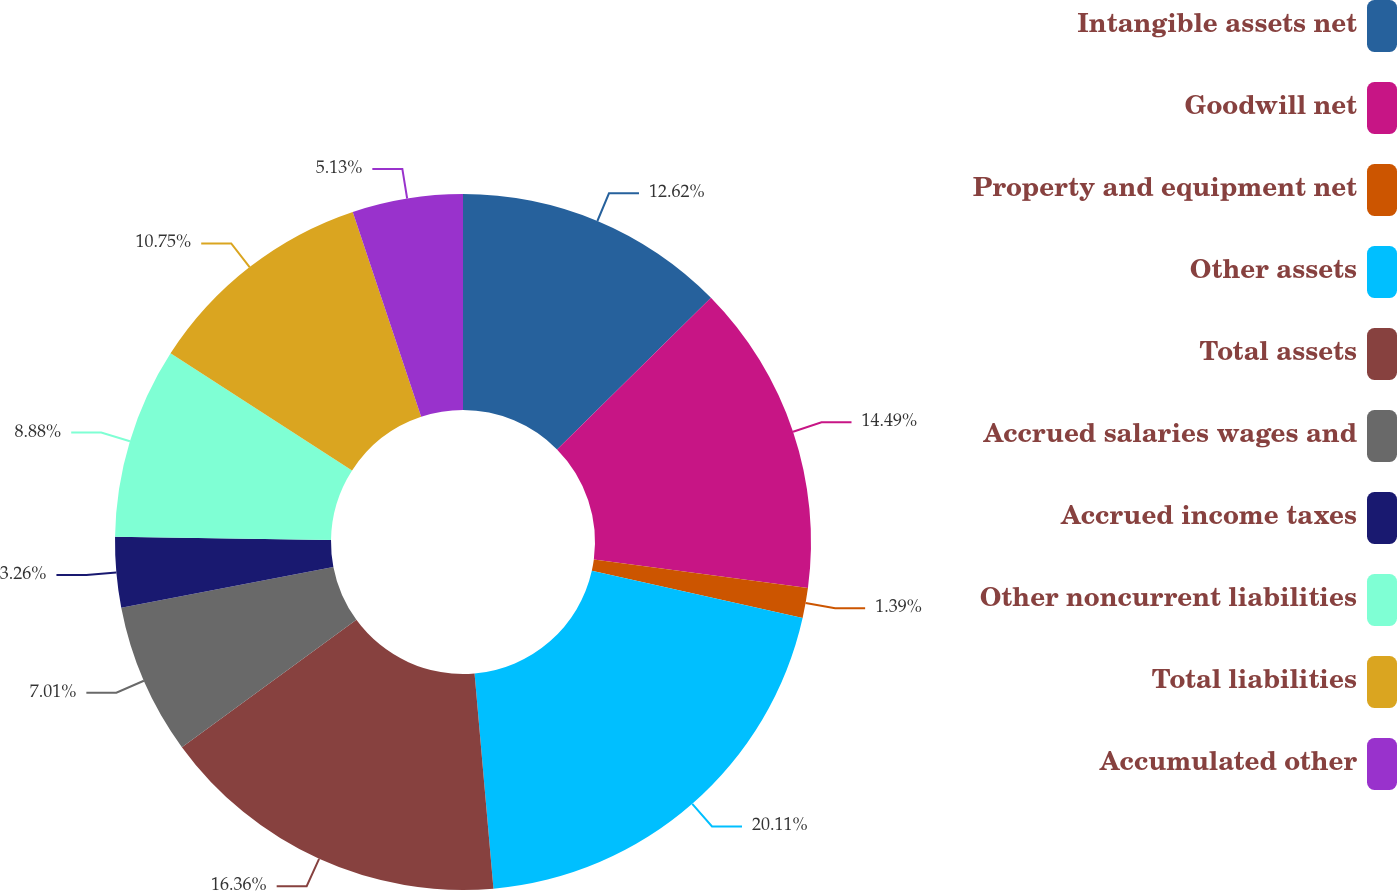<chart> <loc_0><loc_0><loc_500><loc_500><pie_chart><fcel>Intangible assets net<fcel>Goodwill net<fcel>Property and equipment net<fcel>Other assets<fcel>Total assets<fcel>Accrued salaries wages and<fcel>Accrued income taxes<fcel>Other noncurrent liabilities<fcel>Total liabilities<fcel>Accumulated other<nl><fcel>12.62%<fcel>14.49%<fcel>1.39%<fcel>20.1%<fcel>16.36%<fcel>7.01%<fcel>3.26%<fcel>8.88%<fcel>10.75%<fcel>5.13%<nl></chart> 